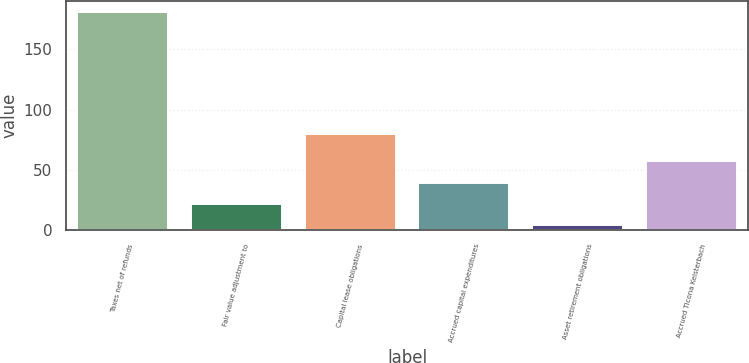Convert chart. <chart><loc_0><loc_0><loc_500><loc_500><bar_chart><fcel>Taxes net of refunds<fcel>Fair value adjustment to<fcel>Capital lease obligations<fcel>Accrued capital expenditures<fcel>Asset retirement obligations<fcel>Accrued Ticona Kelsterbach<nl><fcel>181<fcel>21.7<fcel>80<fcel>39.4<fcel>4<fcel>57.1<nl></chart> 